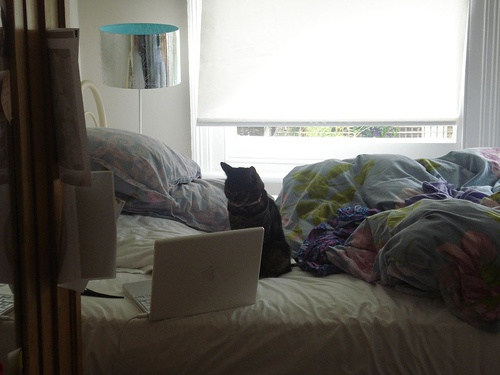Describe the objects in this image and their specific colors. I can see bed in gray, black, white, and darkgray tones, laptop in gray and black tones, and cat in gray, black, and darkgray tones in this image. 